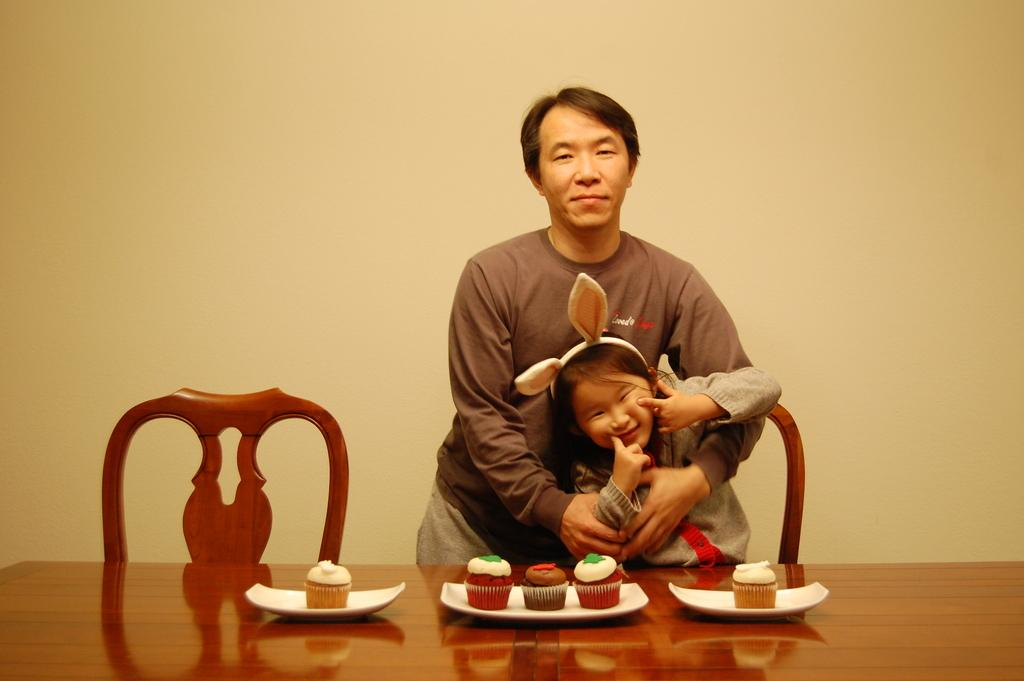What is the setting of the image? There is a room in the image. How many people are in the room? There are two people in the room. What is one person doing with the baby? One person is holding a baby. What furniture is present in the room? There is a table in the room. What items can be seen on the table? There is a cup, cake, and cookies on the table. How many kittens are sitting on the elbow of the person holding the baby? There are no kittens present in the image, and therefore no kittens can be seen sitting on anyone's elbow. 